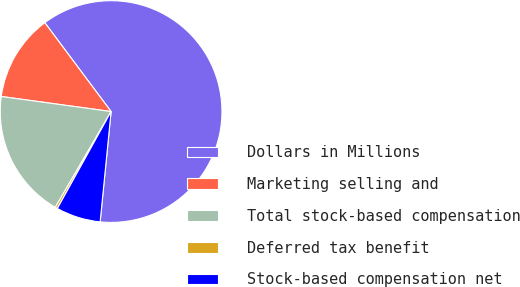<chart> <loc_0><loc_0><loc_500><loc_500><pie_chart><fcel>Dollars in Millions<fcel>Marketing selling and<fcel>Total stock-based compensation<fcel>Deferred tax benefit<fcel>Stock-based compensation net<nl><fcel>61.78%<fcel>12.63%<fcel>18.77%<fcel>0.34%<fcel>6.48%<nl></chart> 